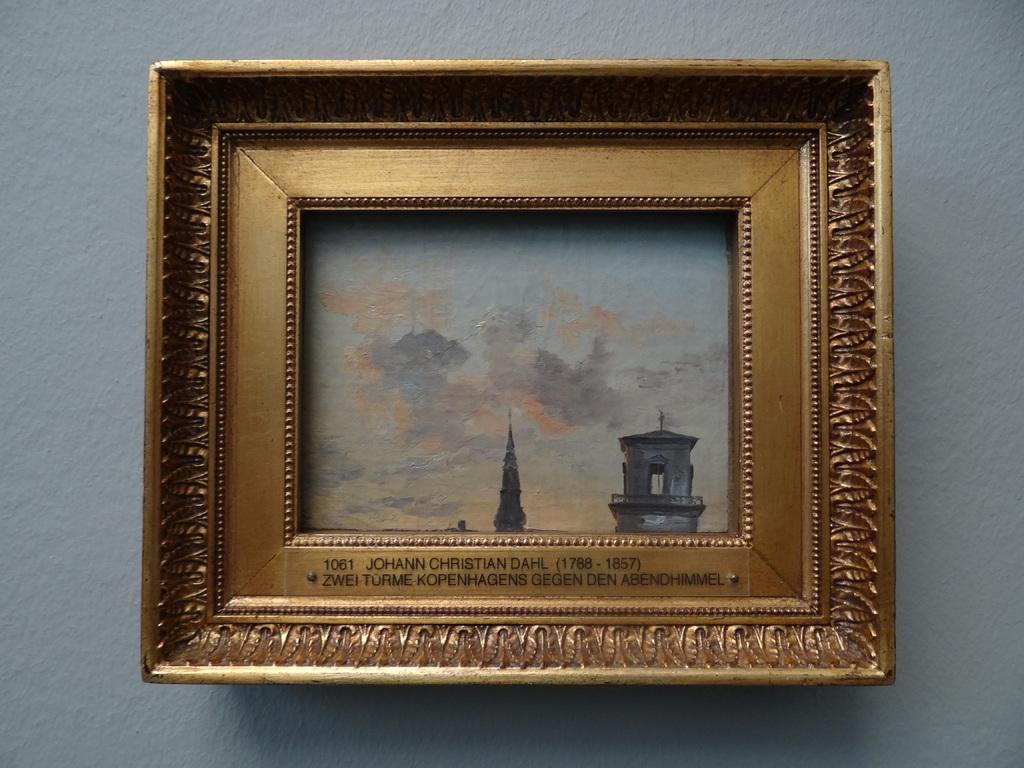<image>
Write a terse but informative summary of the picture. Picture framed on a wall showing a building and the year 1061. 